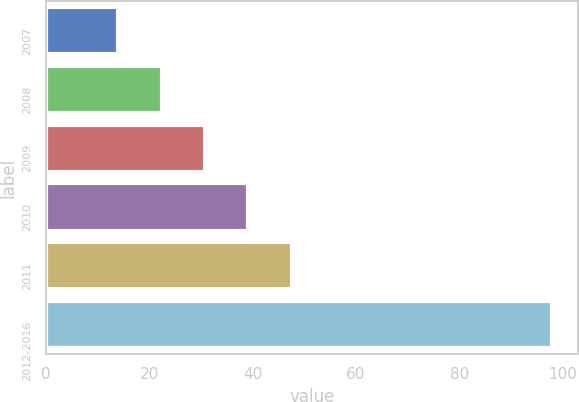Convert chart to OTSL. <chart><loc_0><loc_0><loc_500><loc_500><bar_chart><fcel>2007<fcel>2008<fcel>2009<fcel>2010<fcel>2011<fcel>2012-2016<nl><fcel>14<fcel>22.4<fcel>30.8<fcel>39.2<fcel>47.6<fcel>98<nl></chart> 